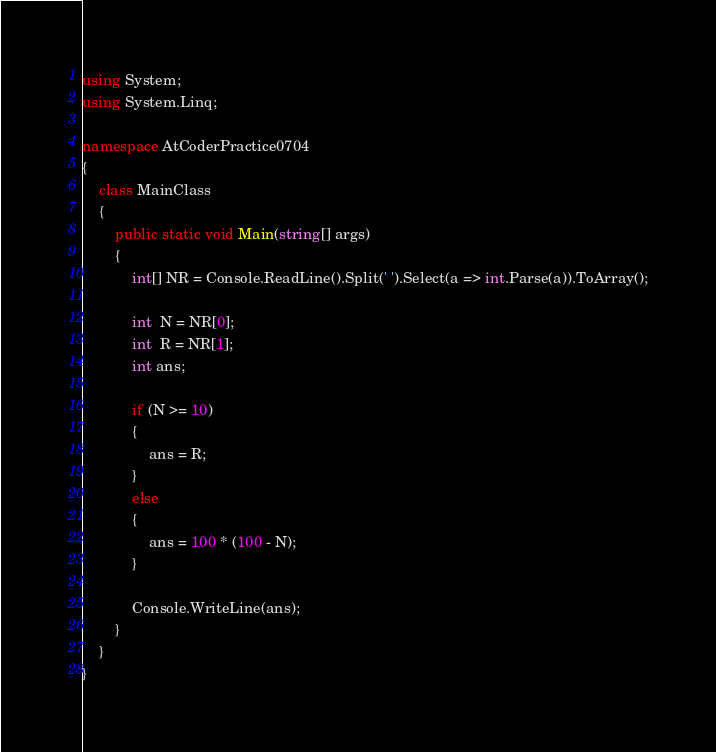Convert code to text. <code><loc_0><loc_0><loc_500><loc_500><_C#_>using System;
using System.Linq;

namespace AtCoderPractice0704
{
    class MainClass
    {
        public static void Main(string[] args)
        {
            int[] NR = Console.ReadLine().Split(' ').Select(a => int.Parse(a)).ToArray();

            int  N = NR[0];
            int  R = NR[1];
            int ans;

            if (N >= 10)
            {
                ans = R;
            }
            else
            {
                ans = 100 * (100 - N);
            }

            Console.WriteLine(ans);
        }
    }
}
</code> 